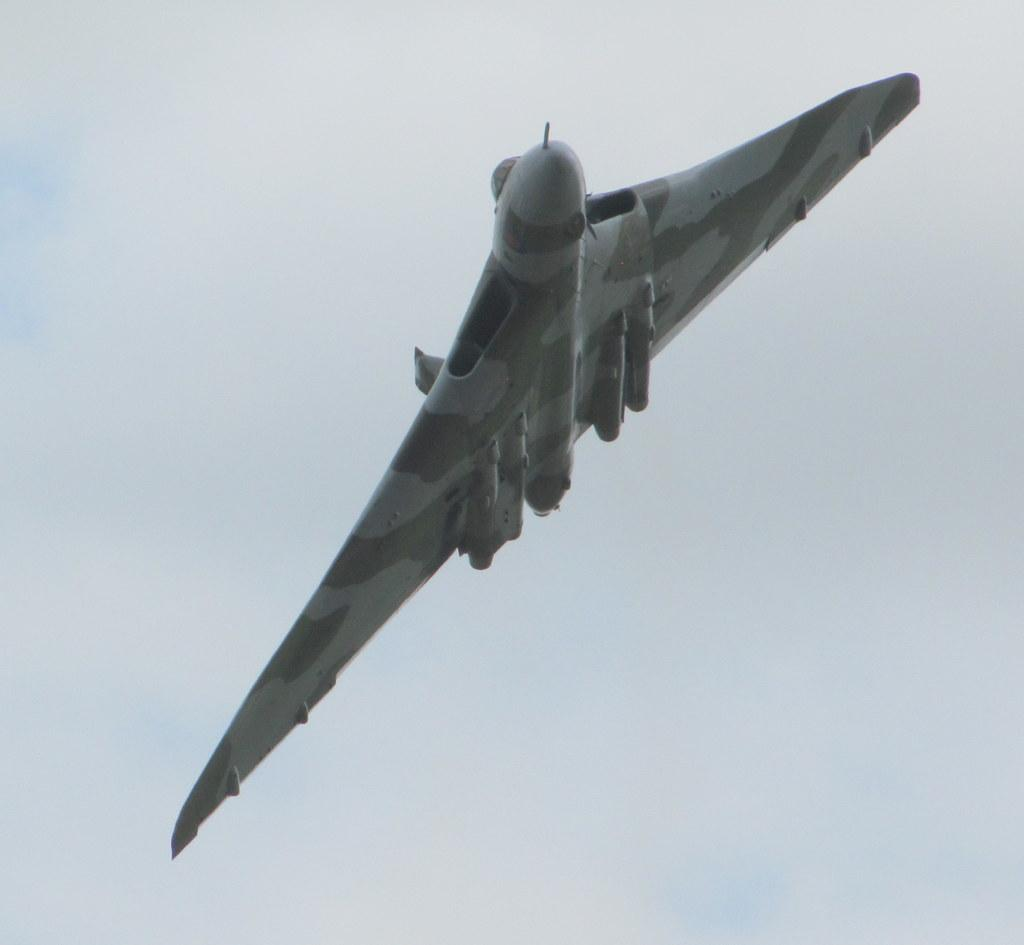What is the main subject of the image? The main subject of the image is an aircraft. What can be seen in the background of the image? The sky is visible behind the aircraft. How would you describe the weather based on the image? The sky is clear, which suggests good weather. What type of brush is being used to paint the plot in the image? There is no brush or plot present in the image; it features an aircraft and a clear sky. 